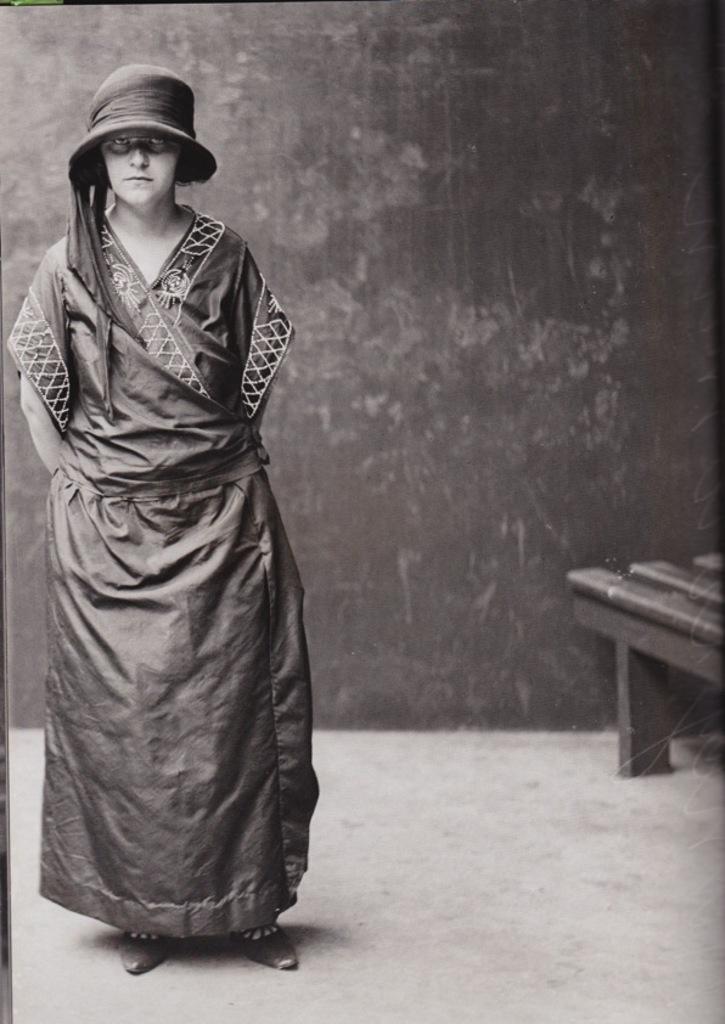Could you give a brief overview of what you see in this image? In this image we can see a lady. A lady is standing in the image. There is a bench at the right side of the image. 